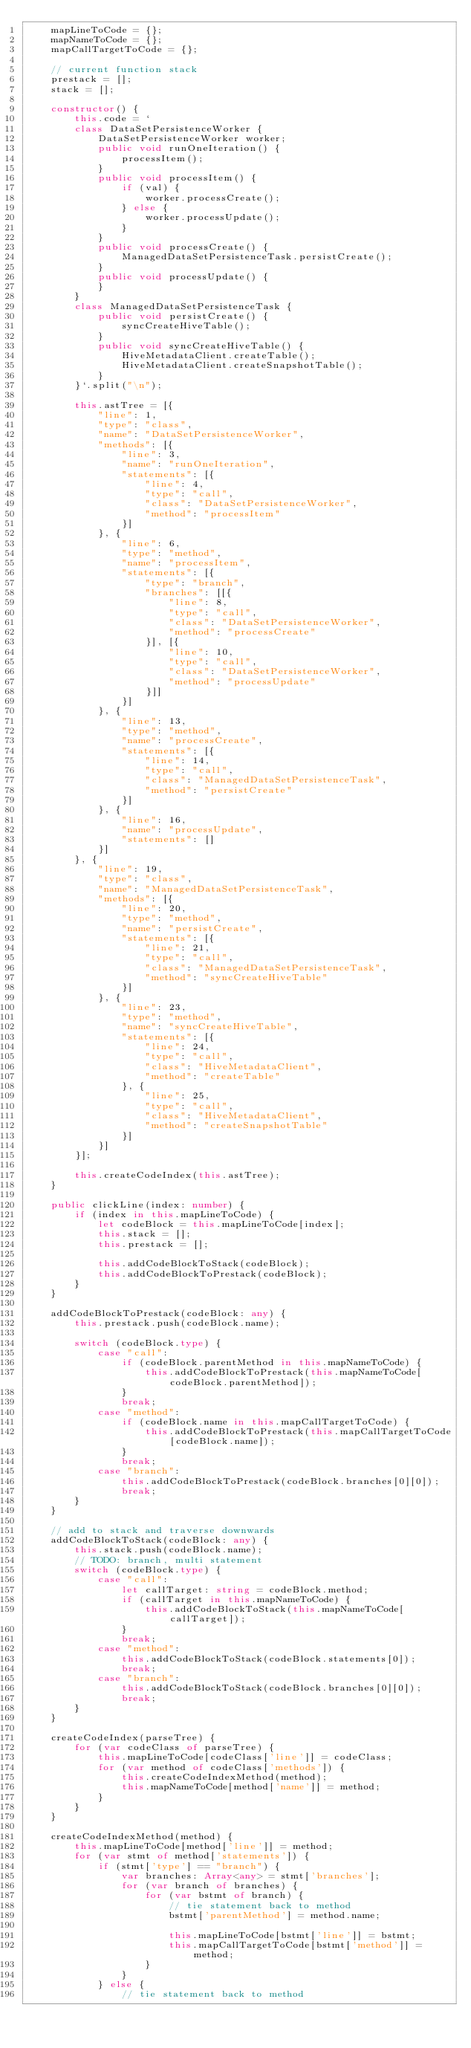Convert code to text. <code><loc_0><loc_0><loc_500><loc_500><_TypeScript_>    mapLineToCode = {};
    mapNameToCode = {};
    mapCallTargetToCode = {};

    // current function stack
    prestack = [];
    stack = [];

    constructor() {
        this.code = `
        class DataSetPersistenceWorker {
            DataSetPersistenceWorker worker;
            public void runOneIteration() {
                processItem();
            }
            public void processItem() {
                if (val) {
                    worker.processCreate();
                } else {
                    worker.processUpdate();
                }
            }
            public void processCreate() {
                ManagedDataSetPersistenceTask.persistCreate();
            }
            public void processUpdate() {
            }
        }
        class ManagedDataSetPersistenceTask {
            public void persistCreate() {
                syncCreateHiveTable();
            }
            public void syncCreateHiveTable() {
                HiveMetadataClient.createTable();
                HiveMetadataClient.createSnapshotTable();
            }
        }`.split("\n");

        this.astTree = [{
            "line": 1,
            "type": "class",
            "name": "DataSetPersistenceWorker",
            "methods": [{
                "line": 3,
                "name": "runOneIteration",
                "statements": [{
                    "line": 4,
                    "type": "call",
                    "class": "DataSetPersistenceWorker",
                    "method": "processItem"
                }]
            }, {
                "line": 6,
                "type": "method",
                "name": "processItem",
                "statements": [{
                    "type": "branch",
                    "branches": [[{
                        "line": 8,
                        "type": "call",
                        "class": "DataSetPersistenceWorker",
                        "method": "processCreate"
                    }], [{
                        "line": 10,
                        "type": "call",
                        "class": "DataSetPersistenceWorker",
                        "method": "processUpdate"
                    }]]
                }]
            }, {
                "line": 13,
                "type": "method",
                "name": "processCreate",
                "statements": [{
                    "line": 14,
                    "type": "call",
                    "class": "ManagedDataSetPersistenceTask",
                    "method": "persistCreate"
                }]
            }, {
                "line": 16,
                "name": "processUpdate",
                "statements": []
            }]
        }, {
            "line": 19,
            "type": "class",
            "name": "ManagedDataSetPersistenceTask",
            "methods": [{
                "line": 20,
                "type": "method",
                "name": "persistCreate",
                "statements": [{
                    "line": 21,
                    "type": "call",
                    "class": "ManagedDataSetPersistenceTask",
                    "method": "syncCreateHiveTable"
                }]
            }, {
                "line": 23,
                "type": "method",
                "name": "syncCreateHiveTable",
                "statements": [{
                    "line": 24,
                    "type": "call",
                    "class": "HiveMetadataClient",
                    "method": "createTable"
                }, {
                    "line": 25,
                    "type": "call",
                    "class": "HiveMetadataClient",
                    "method": "createSnapshotTable"
                }]
            }]
        }];

        this.createCodeIndex(this.astTree);
    }

    public clickLine(index: number) {
        if (index in this.mapLineToCode) {
            let codeBlock = this.mapLineToCode[index];
            this.stack = [];
            this.prestack = [];

            this.addCodeBlockToStack(codeBlock);
            this.addCodeBlockToPrestack(codeBlock);
        }
    }

    addCodeBlockToPrestack(codeBlock: any) {
        this.prestack.push(codeBlock.name);

        switch (codeBlock.type) {
            case "call":
                if (codeBlock.parentMethod in this.mapNameToCode) {
                    this.addCodeBlockToPrestack(this.mapNameToCode[codeBlock.parentMethod]);
                }
                break;
            case "method":
                if (codeBlock.name in this.mapCallTargetToCode) {
                    this.addCodeBlockToPrestack(this.mapCallTargetToCode[codeBlock.name]);
                }
                break;
            case "branch":
                this.addCodeBlockToPrestack(codeBlock.branches[0][0]);
                break;
        }
    }

    // add to stack and traverse downwards
    addCodeBlockToStack(codeBlock: any) {
        this.stack.push(codeBlock.name);
        // TODO: branch, multi statement
        switch (codeBlock.type) {
            case "call":
                let callTarget: string = codeBlock.method;
                if (callTarget in this.mapNameToCode) {
                    this.addCodeBlockToStack(this.mapNameToCode[callTarget]);
                }
                break;
            case "method":
                this.addCodeBlockToStack(codeBlock.statements[0]);
                break;
            case "branch":
                this.addCodeBlockToStack(codeBlock.branches[0][0]);
                break;
        }
    }

    createCodeIndex(parseTree) {
        for (var codeClass of parseTree) {
            this.mapLineToCode[codeClass['line']] = codeClass;
            for (var method of codeClass['methods']) {
                this.createCodeIndexMethod(method);
                this.mapNameToCode[method['name']] = method;
            }
        }
    }

    createCodeIndexMethod(method) {
        this.mapLineToCode[method['line']] = method;
        for (var stmt of method['statements']) {
            if (stmt['type'] == "branch") {
                var branches: Array<any> = stmt['branches'];
                for (var branch of branches) {
                    for (var bstmt of branch) {
                        // tie statement back to method
                        bstmt['parentMethod'] = method.name;

                        this.mapLineToCode[bstmt['line']] = bstmt;
                        this.mapCallTargetToCode[bstmt['method']] = method;
                    }
                }
            } else {
                // tie statement back to method</code> 